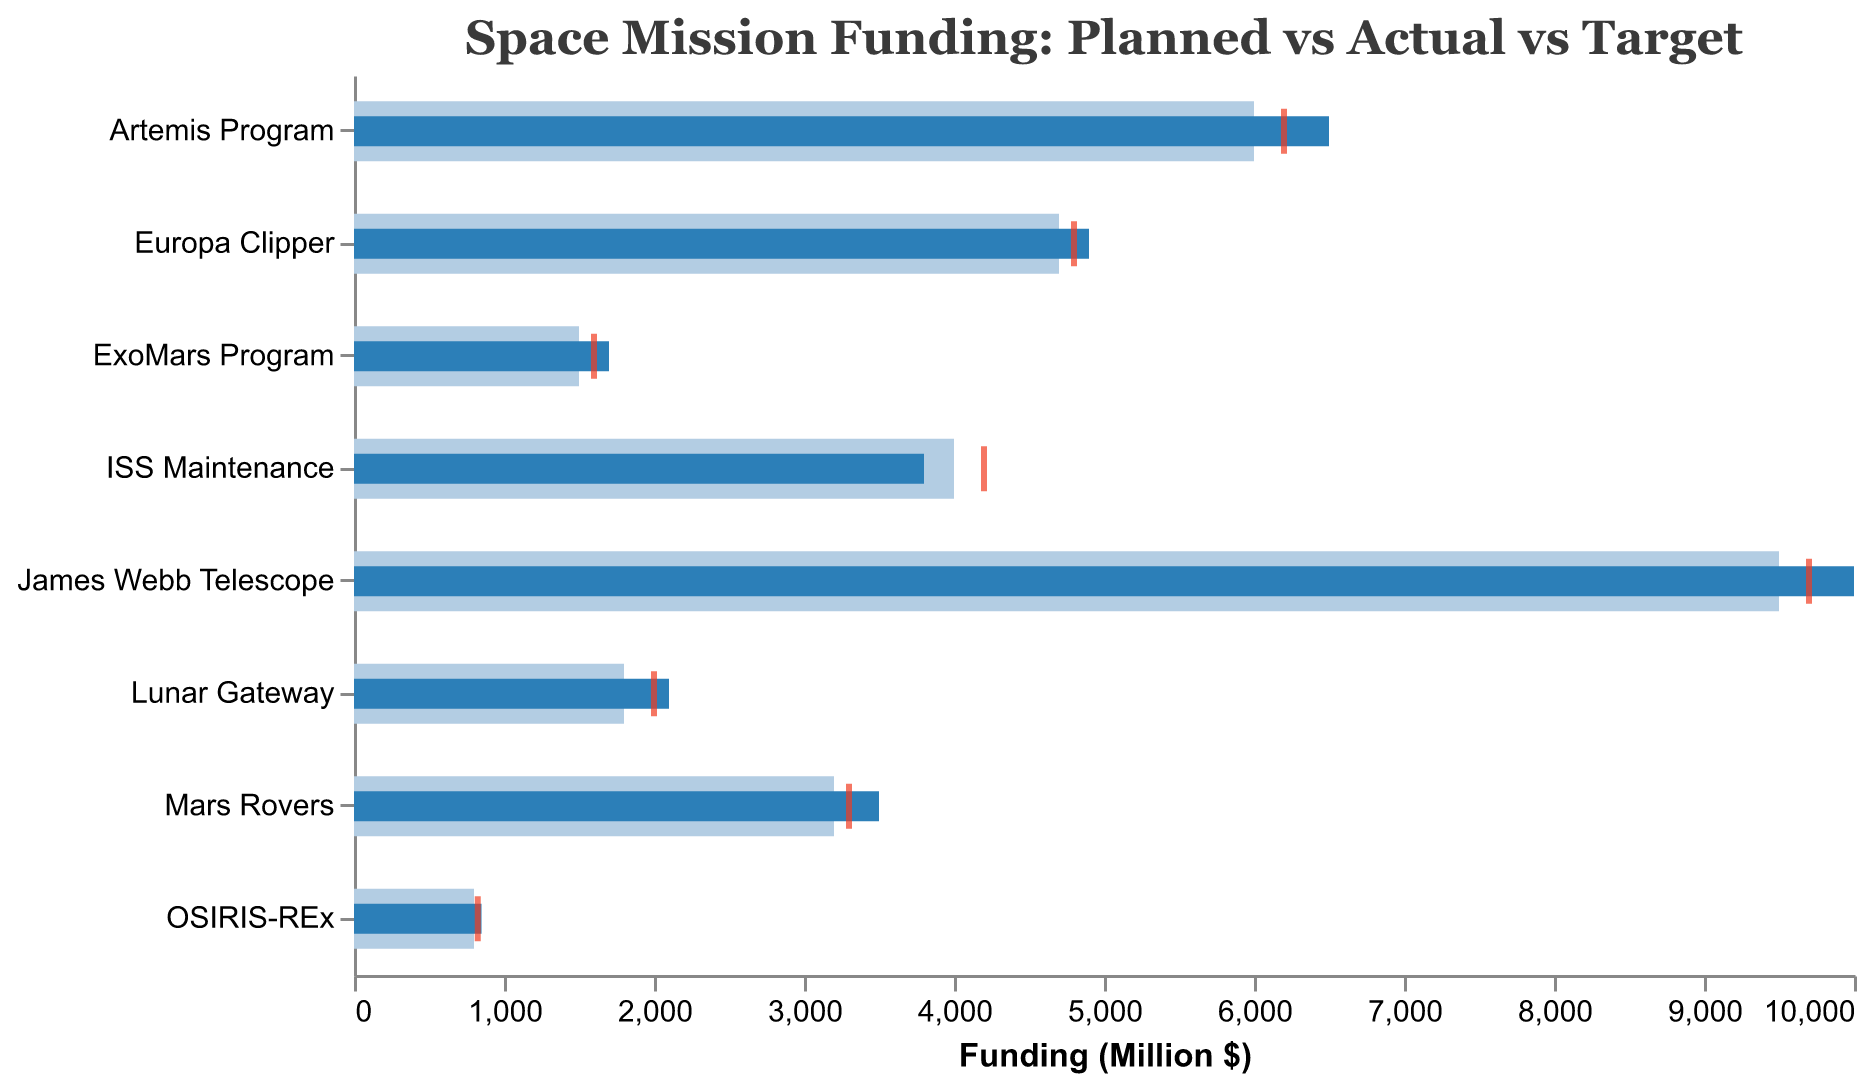What is the title of the chart? The title of the chart is displayed at the top and reads "Space Mission Funding: Planned vs Actual vs Target".
Answer: Space Mission Funding: Planned vs Actual vs Target Which mission type had the highest actual expenditure? To find the mission with the highest actual expenditure, look at the "Actual" expenditure values represented by the darker blue bars. "James Webb Telescope" had the highest actual expenditure of 10,000 million dollars.
Answer: James Webb Telescope How much more did the Mars Rovers mission spend compared to its planned funding? The Mars Rovers mission had a planned funding of 3,200 million dollars and an actual expenditure of 3,500 million dollars. The difference is 3,500 - 3,200 = 300 million dollars.
Answer: 300 million dollars Which mission hit its target expenditure most accurately? Examine the positions of the red ticks (representing target funding) relative to the blue bars (actual expenditure). The OSIRIS-REx mission's Actual Expenditure (850 million dollars) closely matches its Target Funding (825 million dollars).
Answer: OSIRIS-REx Which mission had the biggest overspend relative to the target? Calculate the difference between actual expenditure and target funding for each mission. The James Webb Telescope had an actual expenditure of 10,000 million dollars and a target of 9,700 million dollars, resulting in an overspend of 10,000 - 9,700 = 300 million dollars.
Answer: James Webb Telescope What is the average of the planned funding amounts for the missions? Sum all the planned funding amounts and divide by the number of missions. (3,200 + 9,500 + 4,000 + 1,800 + 1,500 + 800 + 6,000 + 4,700) / 8 = 31,500 / 8 = 3,937.5 million dollars.
Answer: 3,937.5 million dollars How much did the Lunar Gateway mission exceed its planned funding by as a percentage? Calculate the difference between actual expenditure and planned funding, then divide by the planned funding and multiply by 100. (2,100 - 1,800) / 1,800 * 100 = 16.67%.
Answer: 16.67% Which mission's planned funding was closest to its actual expenditure? Compare the difference between planned funding and actual expenditure values for each mission. The Luna Gateway had actual of 2,100 and planned of 1,800, close difference of 300.
Answer: Lunar Gateway What is the total actual expenditure for all missions combined? Sum up all the actual expenditure values: 3,500 + 10,000 + 3,800 + 2,100 + 1,700 + 850 + 6,500 + 4,900 = 33,350 million dollars.
Answer: 33,350 million dollars 